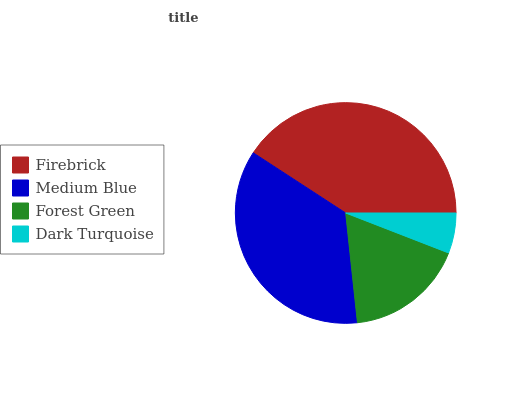Is Dark Turquoise the minimum?
Answer yes or no. Yes. Is Firebrick the maximum?
Answer yes or no. Yes. Is Medium Blue the minimum?
Answer yes or no. No. Is Medium Blue the maximum?
Answer yes or no. No. Is Firebrick greater than Medium Blue?
Answer yes or no. Yes. Is Medium Blue less than Firebrick?
Answer yes or no. Yes. Is Medium Blue greater than Firebrick?
Answer yes or no. No. Is Firebrick less than Medium Blue?
Answer yes or no. No. Is Medium Blue the high median?
Answer yes or no. Yes. Is Forest Green the low median?
Answer yes or no. Yes. Is Forest Green the high median?
Answer yes or no. No. Is Medium Blue the low median?
Answer yes or no. No. 